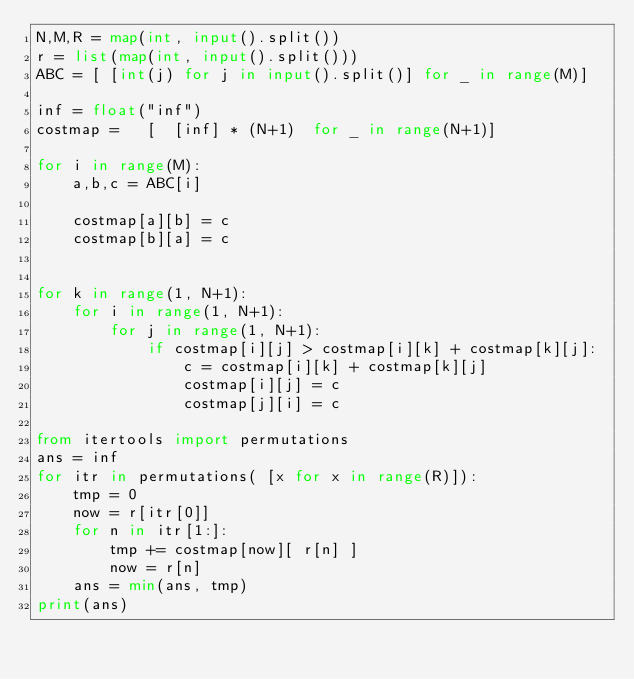<code> <loc_0><loc_0><loc_500><loc_500><_Python_>N,M,R = map(int, input().split())
r = list(map(int, input().split()))
ABC = [ [int(j) for j in input().split()] for _ in range(M)]

inf = float("inf")
costmap =   [  [inf] * (N+1)  for _ in range(N+1)] 

for i in range(M):
    a,b,c = ABC[i]

    costmap[a][b] = c
    costmap[b][a] = c


for k in range(1, N+1):
    for i in range(1, N+1):
        for j in range(1, N+1):
            if costmap[i][j] > costmap[i][k] + costmap[k][j]:
                c = costmap[i][k] + costmap[k][j]
                costmap[i][j] = c
                costmap[j][i] = c

from itertools import permutations
ans = inf
for itr in permutations( [x for x in range(R)]):
    tmp = 0
    now = r[itr[0]]
    for n in itr[1:]:
        tmp += costmap[now][ r[n] ]
        now = r[n]
    ans = min(ans, tmp)
print(ans)

</code> 